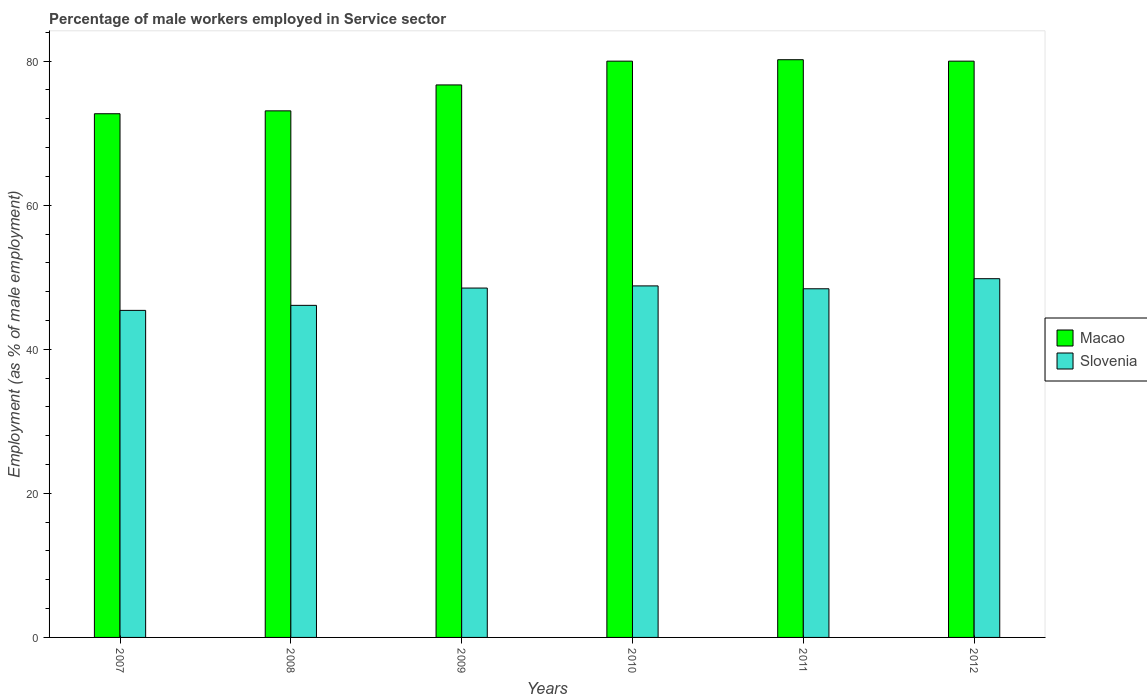How many different coloured bars are there?
Your answer should be very brief. 2. How many groups of bars are there?
Give a very brief answer. 6. Are the number of bars per tick equal to the number of legend labels?
Ensure brevity in your answer.  Yes. Are the number of bars on each tick of the X-axis equal?
Provide a short and direct response. Yes. How many bars are there on the 3rd tick from the right?
Make the answer very short. 2. What is the percentage of male workers employed in Service sector in Macao in 2007?
Your response must be concise. 72.7. Across all years, what is the maximum percentage of male workers employed in Service sector in Slovenia?
Provide a short and direct response. 49.8. Across all years, what is the minimum percentage of male workers employed in Service sector in Macao?
Give a very brief answer. 72.7. In which year was the percentage of male workers employed in Service sector in Slovenia maximum?
Provide a short and direct response. 2012. What is the total percentage of male workers employed in Service sector in Macao in the graph?
Offer a very short reply. 462.7. What is the difference between the percentage of male workers employed in Service sector in Slovenia in 2011 and that in 2012?
Your response must be concise. -1.4. What is the difference between the percentage of male workers employed in Service sector in Slovenia in 2009 and the percentage of male workers employed in Service sector in Macao in 2012?
Give a very brief answer. -31.5. What is the average percentage of male workers employed in Service sector in Macao per year?
Offer a very short reply. 77.12. In the year 2008, what is the difference between the percentage of male workers employed in Service sector in Macao and percentage of male workers employed in Service sector in Slovenia?
Ensure brevity in your answer.  27. In how many years, is the percentage of male workers employed in Service sector in Macao greater than 20 %?
Give a very brief answer. 6. What is the ratio of the percentage of male workers employed in Service sector in Slovenia in 2007 to that in 2010?
Offer a very short reply. 0.93. Is the percentage of male workers employed in Service sector in Slovenia in 2007 less than that in 2009?
Your answer should be compact. Yes. What is the difference between the highest and the second highest percentage of male workers employed in Service sector in Macao?
Provide a succinct answer. 0.2. What is the difference between the highest and the lowest percentage of male workers employed in Service sector in Slovenia?
Keep it short and to the point. 4.4. In how many years, is the percentage of male workers employed in Service sector in Slovenia greater than the average percentage of male workers employed in Service sector in Slovenia taken over all years?
Your answer should be compact. 4. Is the sum of the percentage of male workers employed in Service sector in Slovenia in 2008 and 2011 greater than the maximum percentage of male workers employed in Service sector in Macao across all years?
Offer a very short reply. Yes. What does the 1st bar from the left in 2009 represents?
Your response must be concise. Macao. What does the 1st bar from the right in 2008 represents?
Make the answer very short. Slovenia. How many bars are there?
Offer a terse response. 12. Are all the bars in the graph horizontal?
Your answer should be compact. No. Are the values on the major ticks of Y-axis written in scientific E-notation?
Provide a short and direct response. No. Where does the legend appear in the graph?
Your answer should be very brief. Center right. What is the title of the graph?
Provide a succinct answer. Percentage of male workers employed in Service sector. Does "Estonia" appear as one of the legend labels in the graph?
Your response must be concise. No. What is the label or title of the Y-axis?
Your response must be concise. Employment (as % of male employment). What is the Employment (as % of male employment) of Macao in 2007?
Your response must be concise. 72.7. What is the Employment (as % of male employment) of Slovenia in 2007?
Your answer should be very brief. 45.4. What is the Employment (as % of male employment) of Macao in 2008?
Provide a succinct answer. 73.1. What is the Employment (as % of male employment) in Slovenia in 2008?
Your response must be concise. 46.1. What is the Employment (as % of male employment) of Macao in 2009?
Give a very brief answer. 76.7. What is the Employment (as % of male employment) of Slovenia in 2009?
Provide a short and direct response. 48.5. What is the Employment (as % of male employment) of Slovenia in 2010?
Keep it short and to the point. 48.8. What is the Employment (as % of male employment) of Macao in 2011?
Provide a succinct answer. 80.2. What is the Employment (as % of male employment) in Slovenia in 2011?
Keep it short and to the point. 48.4. What is the Employment (as % of male employment) of Slovenia in 2012?
Provide a short and direct response. 49.8. Across all years, what is the maximum Employment (as % of male employment) in Macao?
Your response must be concise. 80.2. Across all years, what is the maximum Employment (as % of male employment) in Slovenia?
Provide a succinct answer. 49.8. Across all years, what is the minimum Employment (as % of male employment) in Macao?
Provide a short and direct response. 72.7. Across all years, what is the minimum Employment (as % of male employment) in Slovenia?
Keep it short and to the point. 45.4. What is the total Employment (as % of male employment) in Macao in the graph?
Your response must be concise. 462.7. What is the total Employment (as % of male employment) of Slovenia in the graph?
Provide a short and direct response. 287. What is the difference between the Employment (as % of male employment) in Macao in 2007 and that in 2008?
Provide a short and direct response. -0.4. What is the difference between the Employment (as % of male employment) of Slovenia in 2007 and that in 2008?
Give a very brief answer. -0.7. What is the difference between the Employment (as % of male employment) in Macao in 2007 and that in 2009?
Provide a succinct answer. -4. What is the difference between the Employment (as % of male employment) in Slovenia in 2007 and that in 2009?
Your answer should be compact. -3.1. What is the difference between the Employment (as % of male employment) of Macao in 2007 and that in 2010?
Offer a terse response. -7.3. What is the difference between the Employment (as % of male employment) in Macao in 2007 and that in 2011?
Provide a short and direct response. -7.5. What is the difference between the Employment (as % of male employment) in Slovenia in 2007 and that in 2011?
Ensure brevity in your answer.  -3. What is the difference between the Employment (as % of male employment) in Macao in 2007 and that in 2012?
Offer a terse response. -7.3. What is the difference between the Employment (as % of male employment) of Slovenia in 2008 and that in 2010?
Your answer should be compact. -2.7. What is the difference between the Employment (as % of male employment) of Slovenia in 2008 and that in 2011?
Offer a terse response. -2.3. What is the difference between the Employment (as % of male employment) of Slovenia in 2008 and that in 2012?
Keep it short and to the point. -3.7. What is the difference between the Employment (as % of male employment) of Slovenia in 2009 and that in 2010?
Keep it short and to the point. -0.3. What is the difference between the Employment (as % of male employment) of Slovenia in 2009 and that in 2011?
Ensure brevity in your answer.  0.1. What is the difference between the Employment (as % of male employment) of Macao in 2010 and that in 2011?
Your response must be concise. -0.2. What is the difference between the Employment (as % of male employment) of Slovenia in 2010 and that in 2011?
Provide a short and direct response. 0.4. What is the difference between the Employment (as % of male employment) in Slovenia in 2011 and that in 2012?
Provide a succinct answer. -1.4. What is the difference between the Employment (as % of male employment) of Macao in 2007 and the Employment (as % of male employment) of Slovenia in 2008?
Provide a succinct answer. 26.6. What is the difference between the Employment (as % of male employment) in Macao in 2007 and the Employment (as % of male employment) in Slovenia in 2009?
Offer a very short reply. 24.2. What is the difference between the Employment (as % of male employment) in Macao in 2007 and the Employment (as % of male employment) in Slovenia in 2010?
Keep it short and to the point. 23.9. What is the difference between the Employment (as % of male employment) in Macao in 2007 and the Employment (as % of male employment) in Slovenia in 2011?
Offer a very short reply. 24.3. What is the difference between the Employment (as % of male employment) in Macao in 2007 and the Employment (as % of male employment) in Slovenia in 2012?
Provide a succinct answer. 22.9. What is the difference between the Employment (as % of male employment) of Macao in 2008 and the Employment (as % of male employment) of Slovenia in 2009?
Your response must be concise. 24.6. What is the difference between the Employment (as % of male employment) in Macao in 2008 and the Employment (as % of male employment) in Slovenia in 2010?
Keep it short and to the point. 24.3. What is the difference between the Employment (as % of male employment) of Macao in 2008 and the Employment (as % of male employment) of Slovenia in 2011?
Offer a very short reply. 24.7. What is the difference between the Employment (as % of male employment) of Macao in 2008 and the Employment (as % of male employment) of Slovenia in 2012?
Your response must be concise. 23.3. What is the difference between the Employment (as % of male employment) of Macao in 2009 and the Employment (as % of male employment) of Slovenia in 2010?
Your answer should be compact. 27.9. What is the difference between the Employment (as % of male employment) of Macao in 2009 and the Employment (as % of male employment) of Slovenia in 2011?
Provide a short and direct response. 28.3. What is the difference between the Employment (as % of male employment) in Macao in 2009 and the Employment (as % of male employment) in Slovenia in 2012?
Your answer should be very brief. 26.9. What is the difference between the Employment (as % of male employment) in Macao in 2010 and the Employment (as % of male employment) in Slovenia in 2011?
Your answer should be very brief. 31.6. What is the difference between the Employment (as % of male employment) of Macao in 2010 and the Employment (as % of male employment) of Slovenia in 2012?
Provide a succinct answer. 30.2. What is the difference between the Employment (as % of male employment) of Macao in 2011 and the Employment (as % of male employment) of Slovenia in 2012?
Make the answer very short. 30.4. What is the average Employment (as % of male employment) of Macao per year?
Provide a short and direct response. 77.12. What is the average Employment (as % of male employment) in Slovenia per year?
Offer a terse response. 47.83. In the year 2007, what is the difference between the Employment (as % of male employment) of Macao and Employment (as % of male employment) of Slovenia?
Provide a succinct answer. 27.3. In the year 2008, what is the difference between the Employment (as % of male employment) of Macao and Employment (as % of male employment) of Slovenia?
Your answer should be very brief. 27. In the year 2009, what is the difference between the Employment (as % of male employment) in Macao and Employment (as % of male employment) in Slovenia?
Ensure brevity in your answer.  28.2. In the year 2010, what is the difference between the Employment (as % of male employment) in Macao and Employment (as % of male employment) in Slovenia?
Offer a very short reply. 31.2. In the year 2011, what is the difference between the Employment (as % of male employment) of Macao and Employment (as % of male employment) of Slovenia?
Give a very brief answer. 31.8. In the year 2012, what is the difference between the Employment (as % of male employment) in Macao and Employment (as % of male employment) in Slovenia?
Offer a terse response. 30.2. What is the ratio of the Employment (as % of male employment) in Macao in 2007 to that in 2008?
Your answer should be compact. 0.99. What is the ratio of the Employment (as % of male employment) of Macao in 2007 to that in 2009?
Offer a terse response. 0.95. What is the ratio of the Employment (as % of male employment) of Slovenia in 2007 to that in 2009?
Your answer should be compact. 0.94. What is the ratio of the Employment (as % of male employment) of Macao in 2007 to that in 2010?
Offer a terse response. 0.91. What is the ratio of the Employment (as % of male employment) of Slovenia in 2007 to that in 2010?
Your answer should be very brief. 0.93. What is the ratio of the Employment (as % of male employment) of Macao in 2007 to that in 2011?
Offer a terse response. 0.91. What is the ratio of the Employment (as % of male employment) of Slovenia in 2007 to that in 2011?
Ensure brevity in your answer.  0.94. What is the ratio of the Employment (as % of male employment) of Macao in 2007 to that in 2012?
Ensure brevity in your answer.  0.91. What is the ratio of the Employment (as % of male employment) in Slovenia in 2007 to that in 2012?
Ensure brevity in your answer.  0.91. What is the ratio of the Employment (as % of male employment) in Macao in 2008 to that in 2009?
Your response must be concise. 0.95. What is the ratio of the Employment (as % of male employment) of Slovenia in 2008 to that in 2009?
Offer a very short reply. 0.95. What is the ratio of the Employment (as % of male employment) in Macao in 2008 to that in 2010?
Offer a terse response. 0.91. What is the ratio of the Employment (as % of male employment) of Slovenia in 2008 to that in 2010?
Provide a short and direct response. 0.94. What is the ratio of the Employment (as % of male employment) in Macao in 2008 to that in 2011?
Provide a succinct answer. 0.91. What is the ratio of the Employment (as % of male employment) of Slovenia in 2008 to that in 2011?
Your response must be concise. 0.95. What is the ratio of the Employment (as % of male employment) of Macao in 2008 to that in 2012?
Offer a terse response. 0.91. What is the ratio of the Employment (as % of male employment) in Slovenia in 2008 to that in 2012?
Provide a succinct answer. 0.93. What is the ratio of the Employment (as % of male employment) in Macao in 2009 to that in 2010?
Provide a short and direct response. 0.96. What is the ratio of the Employment (as % of male employment) of Macao in 2009 to that in 2011?
Make the answer very short. 0.96. What is the ratio of the Employment (as % of male employment) in Macao in 2009 to that in 2012?
Keep it short and to the point. 0.96. What is the ratio of the Employment (as % of male employment) of Slovenia in 2009 to that in 2012?
Give a very brief answer. 0.97. What is the ratio of the Employment (as % of male employment) of Macao in 2010 to that in 2011?
Offer a very short reply. 1. What is the ratio of the Employment (as % of male employment) of Slovenia in 2010 to that in 2011?
Give a very brief answer. 1.01. What is the ratio of the Employment (as % of male employment) in Slovenia in 2010 to that in 2012?
Your answer should be very brief. 0.98. What is the ratio of the Employment (as % of male employment) of Slovenia in 2011 to that in 2012?
Ensure brevity in your answer.  0.97. What is the difference between the highest and the second highest Employment (as % of male employment) in Slovenia?
Keep it short and to the point. 1. 